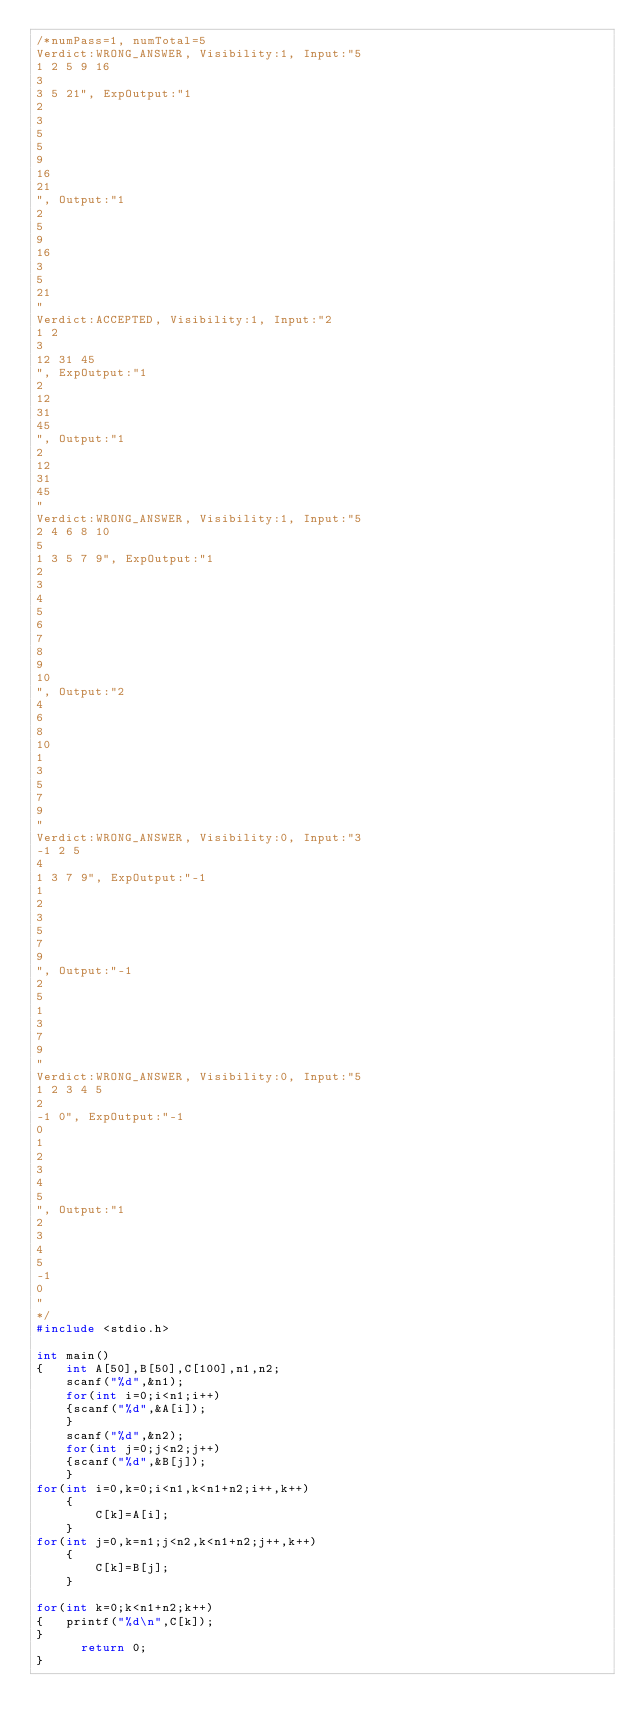<code> <loc_0><loc_0><loc_500><loc_500><_C_>/*numPass=1, numTotal=5
Verdict:WRONG_ANSWER, Visibility:1, Input:"5
1 2 5 9 16
3
3 5 21", ExpOutput:"1
2
3
5
5
9
16
21
", Output:"1
2
5
9
16
3
5
21
"
Verdict:ACCEPTED, Visibility:1, Input:"2
1 2
3
12 31 45
", ExpOutput:"1
2
12
31
45
", Output:"1
2
12
31
45
"
Verdict:WRONG_ANSWER, Visibility:1, Input:"5
2 4 6 8 10
5
1 3 5 7 9", ExpOutput:"1
2
3
4
5
6
7
8
9
10
", Output:"2
4
6
8
10
1
3
5
7
9
"
Verdict:WRONG_ANSWER, Visibility:0, Input:"3
-1 2 5
4
1 3 7 9", ExpOutput:"-1
1
2
3
5
7
9
", Output:"-1
2
5
1
3
7
9
"
Verdict:WRONG_ANSWER, Visibility:0, Input:"5
1 2 3 4 5
2
-1 0", ExpOutput:"-1
0
1
2
3
4
5
", Output:"1
2
3
4
5
-1
0
"
*/
#include <stdio.h>

int main() 
{   int A[50],B[50],C[100],n1,n2;
    scanf("%d",&n1);
    for(int i=0;i<n1;i++)
    {scanf("%d",&A[i]);
    }
    scanf("%d",&n2);
    for(int j=0;j<n2;j++)
    {scanf("%d",&B[j]);
    }
for(int i=0,k=0;i<n1,k<n1+n2;i++,k++)
    {  
        C[k]=A[i];
    }
for(int j=0,k=n1;j<n2,k<n1+n2;j++,k++)
    {   
        C[k]=B[j];
    }

for(int k=0;k<n1+n2;k++)
{   printf("%d\n",C[k]);
}
    	return 0;
}</code> 